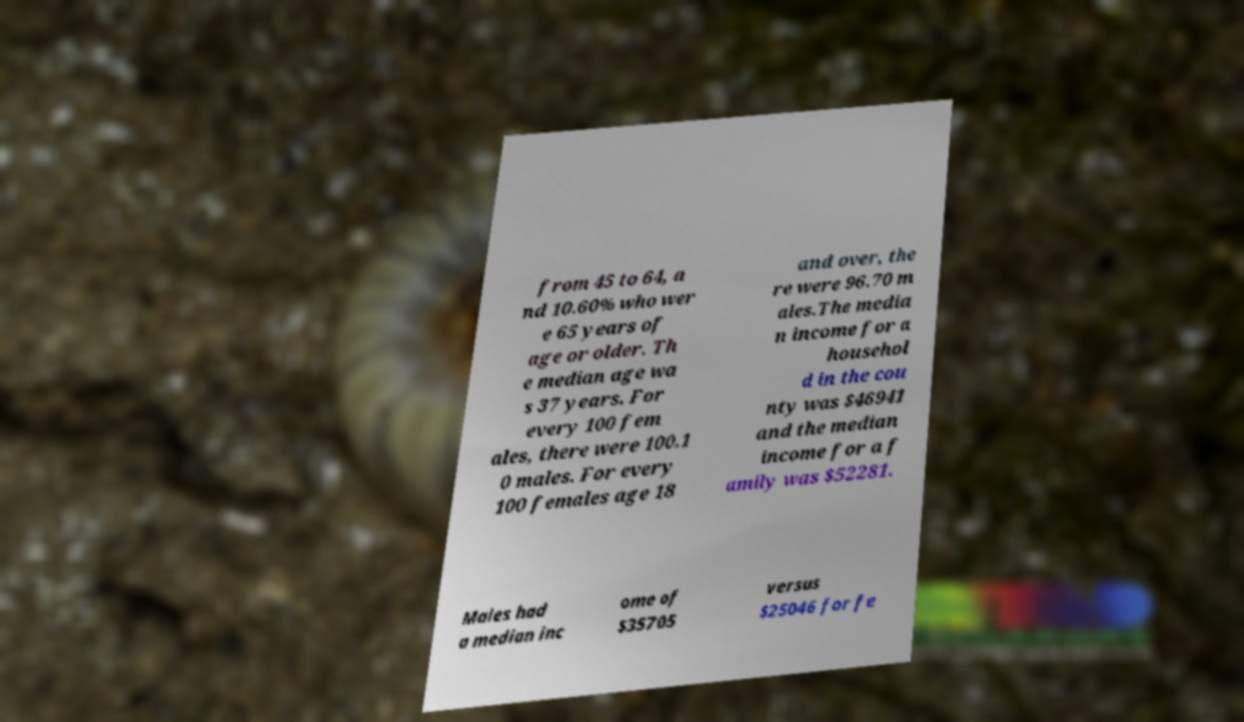There's text embedded in this image that I need extracted. Can you transcribe it verbatim? from 45 to 64, a nd 10.60% who wer e 65 years of age or older. Th e median age wa s 37 years. For every 100 fem ales, there were 100.1 0 males. For every 100 females age 18 and over, the re were 96.70 m ales.The media n income for a househol d in the cou nty was $46941 and the median income for a f amily was $52281. Males had a median inc ome of $35705 versus $25046 for fe 